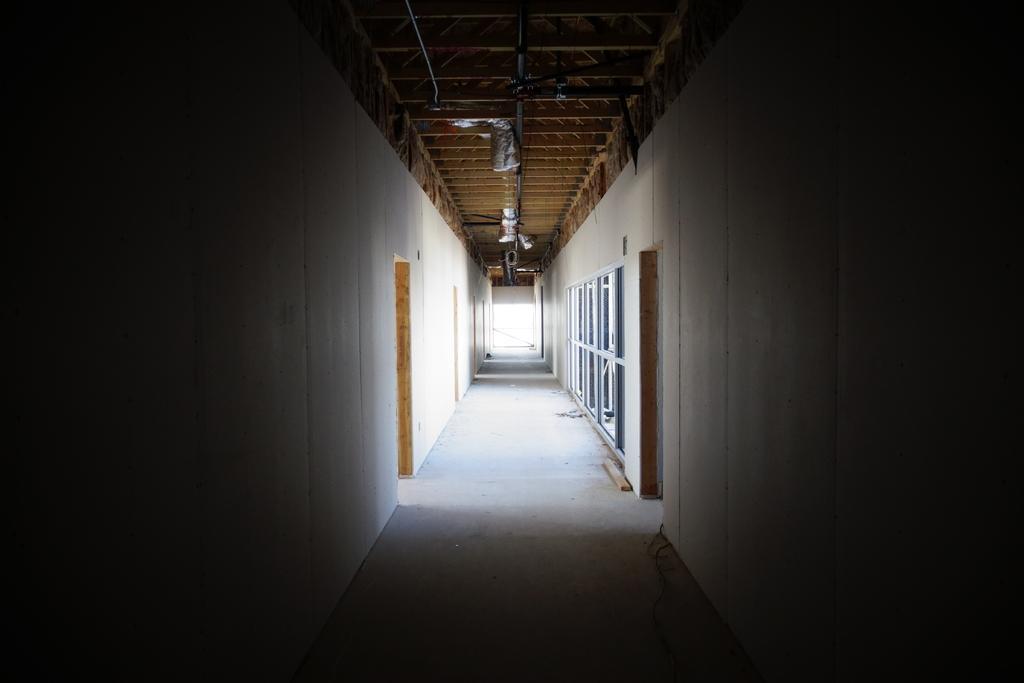Can you describe this image briefly? In this image, we can see the way and we can see walls and doors, at the top, we can see the shed. 